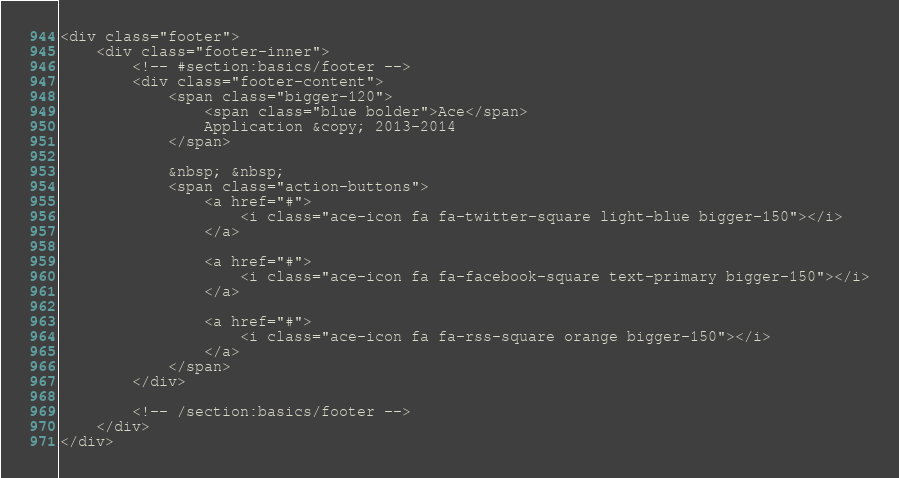Convert code to text. <code><loc_0><loc_0><loc_500><loc_500><_PHP_><div class="footer">
    <div class="footer-inner">
        <!-- #section:basics/footer -->
        <div class="footer-content">
            <span class="bigger-120">
                <span class="blue bolder">Ace</span>
                Application &copy; 2013-2014
            </span>

            &nbsp; &nbsp;
            <span class="action-buttons">
                <a href="#">
                    <i class="ace-icon fa fa-twitter-square light-blue bigger-150"></i>
                </a>

                <a href="#">
                    <i class="ace-icon fa fa-facebook-square text-primary bigger-150"></i>
                </a>

                <a href="#">
                    <i class="ace-icon fa fa-rss-square orange bigger-150"></i>
                </a>
            </span>
        </div>

        <!-- /section:basics/footer -->
    </div>
</div>
</code> 